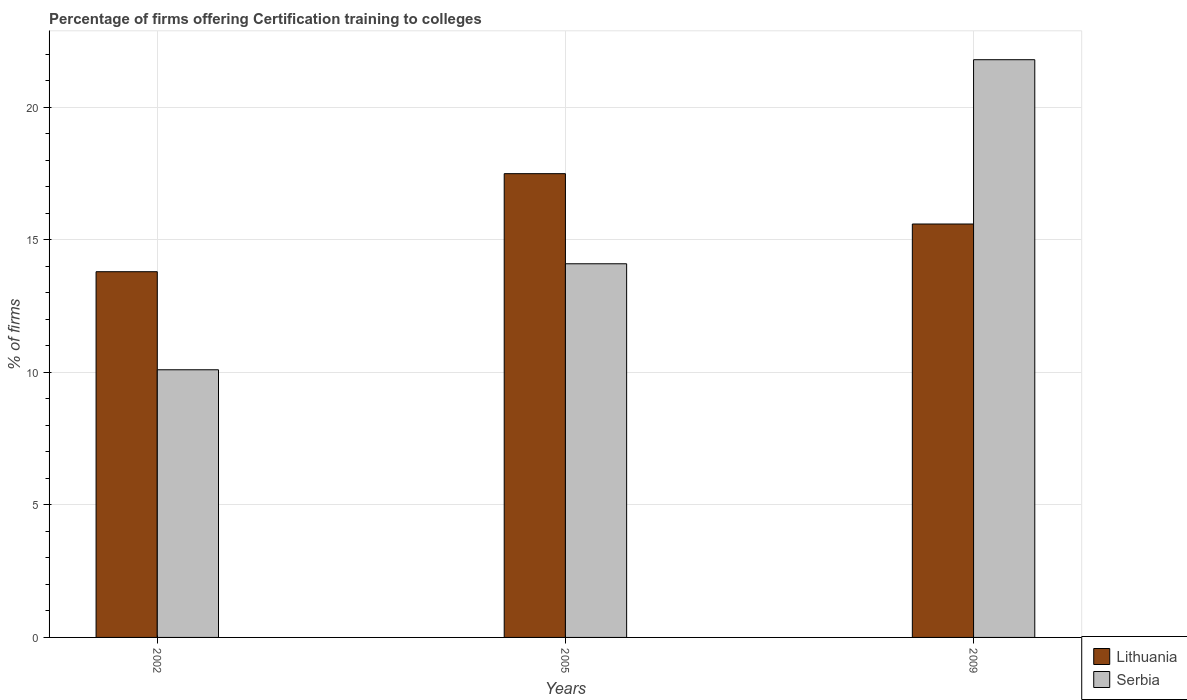How many different coloured bars are there?
Give a very brief answer. 2. How many bars are there on the 1st tick from the left?
Give a very brief answer. 2. What is the label of the 3rd group of bars from the left?
Give a very brief answer. 2009. Across all years, what is the maximum percentage of firms offering certification training to colleges in Serbia?
Provide a short and direct response. 21.8. Across all years, what is the minimum percentage of firms offering certification training to colleges in Serbia?
Your answer should be very brief. 10.1. In which year was the percentage of firms offering certification training to colleges in Lithuania minimum?
Provide a short and direct response. 2002. What is the total percentage of firms offering certification training to colleges in Serbia in the graph?
Your answer should be compact. 46. What is the difference between the percentage of firms offering certification training to colleges in Lithuania in 2002 and that in 2005?
Your answer should be compact. -3.7. What is the average percentage of firms offering certification training to colleges in Serbia per year?
Your answer should be compact. 15.33. In the year 2005, what is the difference between the percentage of firms offering certification training to colleges in Serbia and percentage of firms offering certification training to colleges in Lithuania?
Make the answer very short. -3.4. What is the ratio of the percentage of firms offering certification training to colleges in Lithuania in 2005 to that in 2009?
Your answer should be very brief. 1.12. What is the difference between the highest and the second highest percentage of firms offering certification training to colleges in Serbia?
Your response must be concise. 7.7. What is the difference between the highest and the lowest percentage of firms offering certification training to colleges in Serbia?
Provide a short and direct response. 11.7. In how many years, is the percentage of firms offering certification training to colleges in Serbia greater than the average percentage of firms offering certification training to colleges in Serbia taken over all years?
Provide a succinct answer. 1. Is the sum of the percentage of firms offering certification training to colleges in Lithuania in 2002 and 2005 greater than the maximum percentage of firms offering certification training to colleges in Serbia across all years?
Offer a terse response. Yes. What does the 1st bar from the left in 2009 represents?
Offer a very short reply. Lithuania. What does the 1st bar from the right in 2009 represents?
Your response must be concise. Serbia. What is the difference between two consecutive major ticks on the Y-axis?
Offer a very short reply. 5. Are the values on the major ticks of Y-axis written in scientific E-notation?
Offer a very short reply. No. Does the graph contain any zero values?
Ensure brevity in your answer.  No. How are the legend labels stacked?
Provide a succinct answer. Vertical. What is the title of the graph?
Your response must be concise. Percentage of firms offering Certification training to colleges. Does "Sierra Leone" appear as one of the legend labels in the graph?
Ensure brevity in your answer.  No. What is the label or title of the X-axis?
Offer a terse response. Years. What is the label or title of the Y-axis?
Ensure brevity in your answer.  % of firms. What is the % of firms of Serbia in 2005?
Provide a succinct answer. 14.1. What is the % of firms of Serbia in 2009?
Make the answer very short. 21.8. Across all years, what is the maximum % of firms in Serbia?
Give a very brief answer. 21.8. Across all years, what is the minimum % of firms in Lithuania?
Make the answer very short. 13.8. Across all years, what is the minimum % of firms of Serbia?
Offer a very short reply. 10.1. What is the total % of firms in Lithuania in the graph?
Give a very brief answer. 46.9. What is the difference between the % of firms of Lithuania in 2002 and that in 2005?
Keep it short and to the point. -3.7. What is the difference between the % of firms of Serbia in 2002 and that in 2005?
Give a very brief answer. -4. What is the difference between the % of firms of Lithuania in 2002 and that in 2009?
Your answer should be compact. -1.8. What is the difference between the % of firms in Serbia in 2002 and that in 2009?
Offer a very short reply. -11.7. What is the difference between the % of firms of Lithuania in 2005 and that in 2009?
Offer a terse response. 1.9. What is the difference between the % of firms in Serbia in 2005 and that in 2009?
Make the answer very short. -7.7. What is the difference between the % of firms of Lithuania in 2002 and the % of firms of Serbia in 2005?
Offer a terse response. -0.3. What is the difference between the % of firms in Lithuania in 2002 and the % of firms in Serbia in 2009?
Provide a short and direct response. -8. What is the difference between the % of firms of Lithuania in 2005 and the % of firms of Serbia in 2009?
Your response must be concise. -4.3. What is the average % of firms of Lithuania per year?
Provide a short and direct response. 15.63. What is the average % of firms in Serbia per year?
Provide a succinct answer. 15.33. In the year 2005, what is the difference between the % of firms in Lithuania and % of firms in Serbia?
Offer a terse response. 3.4. In the year 2009, what is the difference between the % of firms in Lithuania and % of firms in Serbia?
Ensure brevity in your answer.  -6.2. What is the ratio of the % of firms in Lithuania in 2002 to that in 2005?
Make the answer very short. 0.79. What is the ratio of the % of firms in Serbia in 2002 to that in 2005?
Ensure brevity in your answer.  0.72. What is the ratio of the % of firms of Lithuania in 2002 to that in 2009?
Offer a terse response. 0.88. What is the ratio of the % of firms in Serbia in 2002 to that in 2009?
Ensure brevity in your answer.  0.46. What is the ratio of the % of firms in Lithuania in 2005 to that in 2009?
Provide a short and direct response. 1.12. What is the ratio of the % of firms in Serbia in 2005 to that in 2009?
Your answer should be very brief. 0.65. What is the difference between the highest and the second highest % of firms in Lithuania?
Keep it short and to the point. 1.9. What is the difference between the highest and the lowest % of firms in Lithuania?
Your response must be concise. 3.7. 